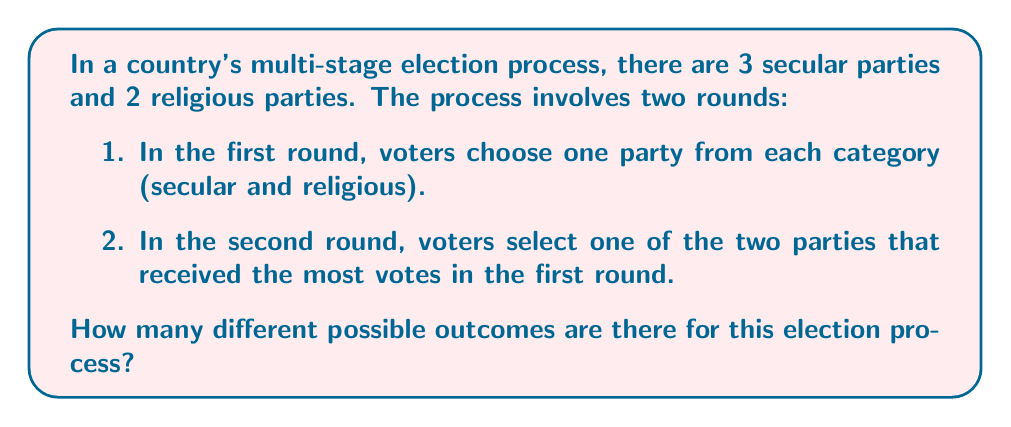Could you help me with this problem? Let's break this down step-by-step:

1. First round:
   - For the secular category, there are 3 choices.
   - For the religious category, there are 2 choices.
   - The number of possible combinations in the first round is:
     $3 \times 2 = 6$

2. Second round:
   - Two parties advance to the second round.
   - These can be any two parties from the total of 5 parties.
   - The number of ways to choose 2 parties from 5 is given by the combination formula:
     $$\binom{5}{2} = \frac{5!}{2!(5-2)!} = \frac{5 \times 4}{2 \times 1} = 10$$

3. Final outcome:
   - For each possible pair in the second round, there are 2 possible winners.
   - So, we multiply the number of possible pairs by 2:
     $10 \times 2 = 20$

Therefore, the total number of possible outcomes is 20.
Answer: 20 